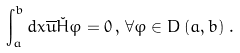<formula> <loc_0><loc_0><loc_500><loc_500>\int _ { a } ^ { b } d x \overline { u } \check { H } \varphi = 0 \, , \, \forall \varphi \in D \left ( a , b \right ) \, .</formula> 